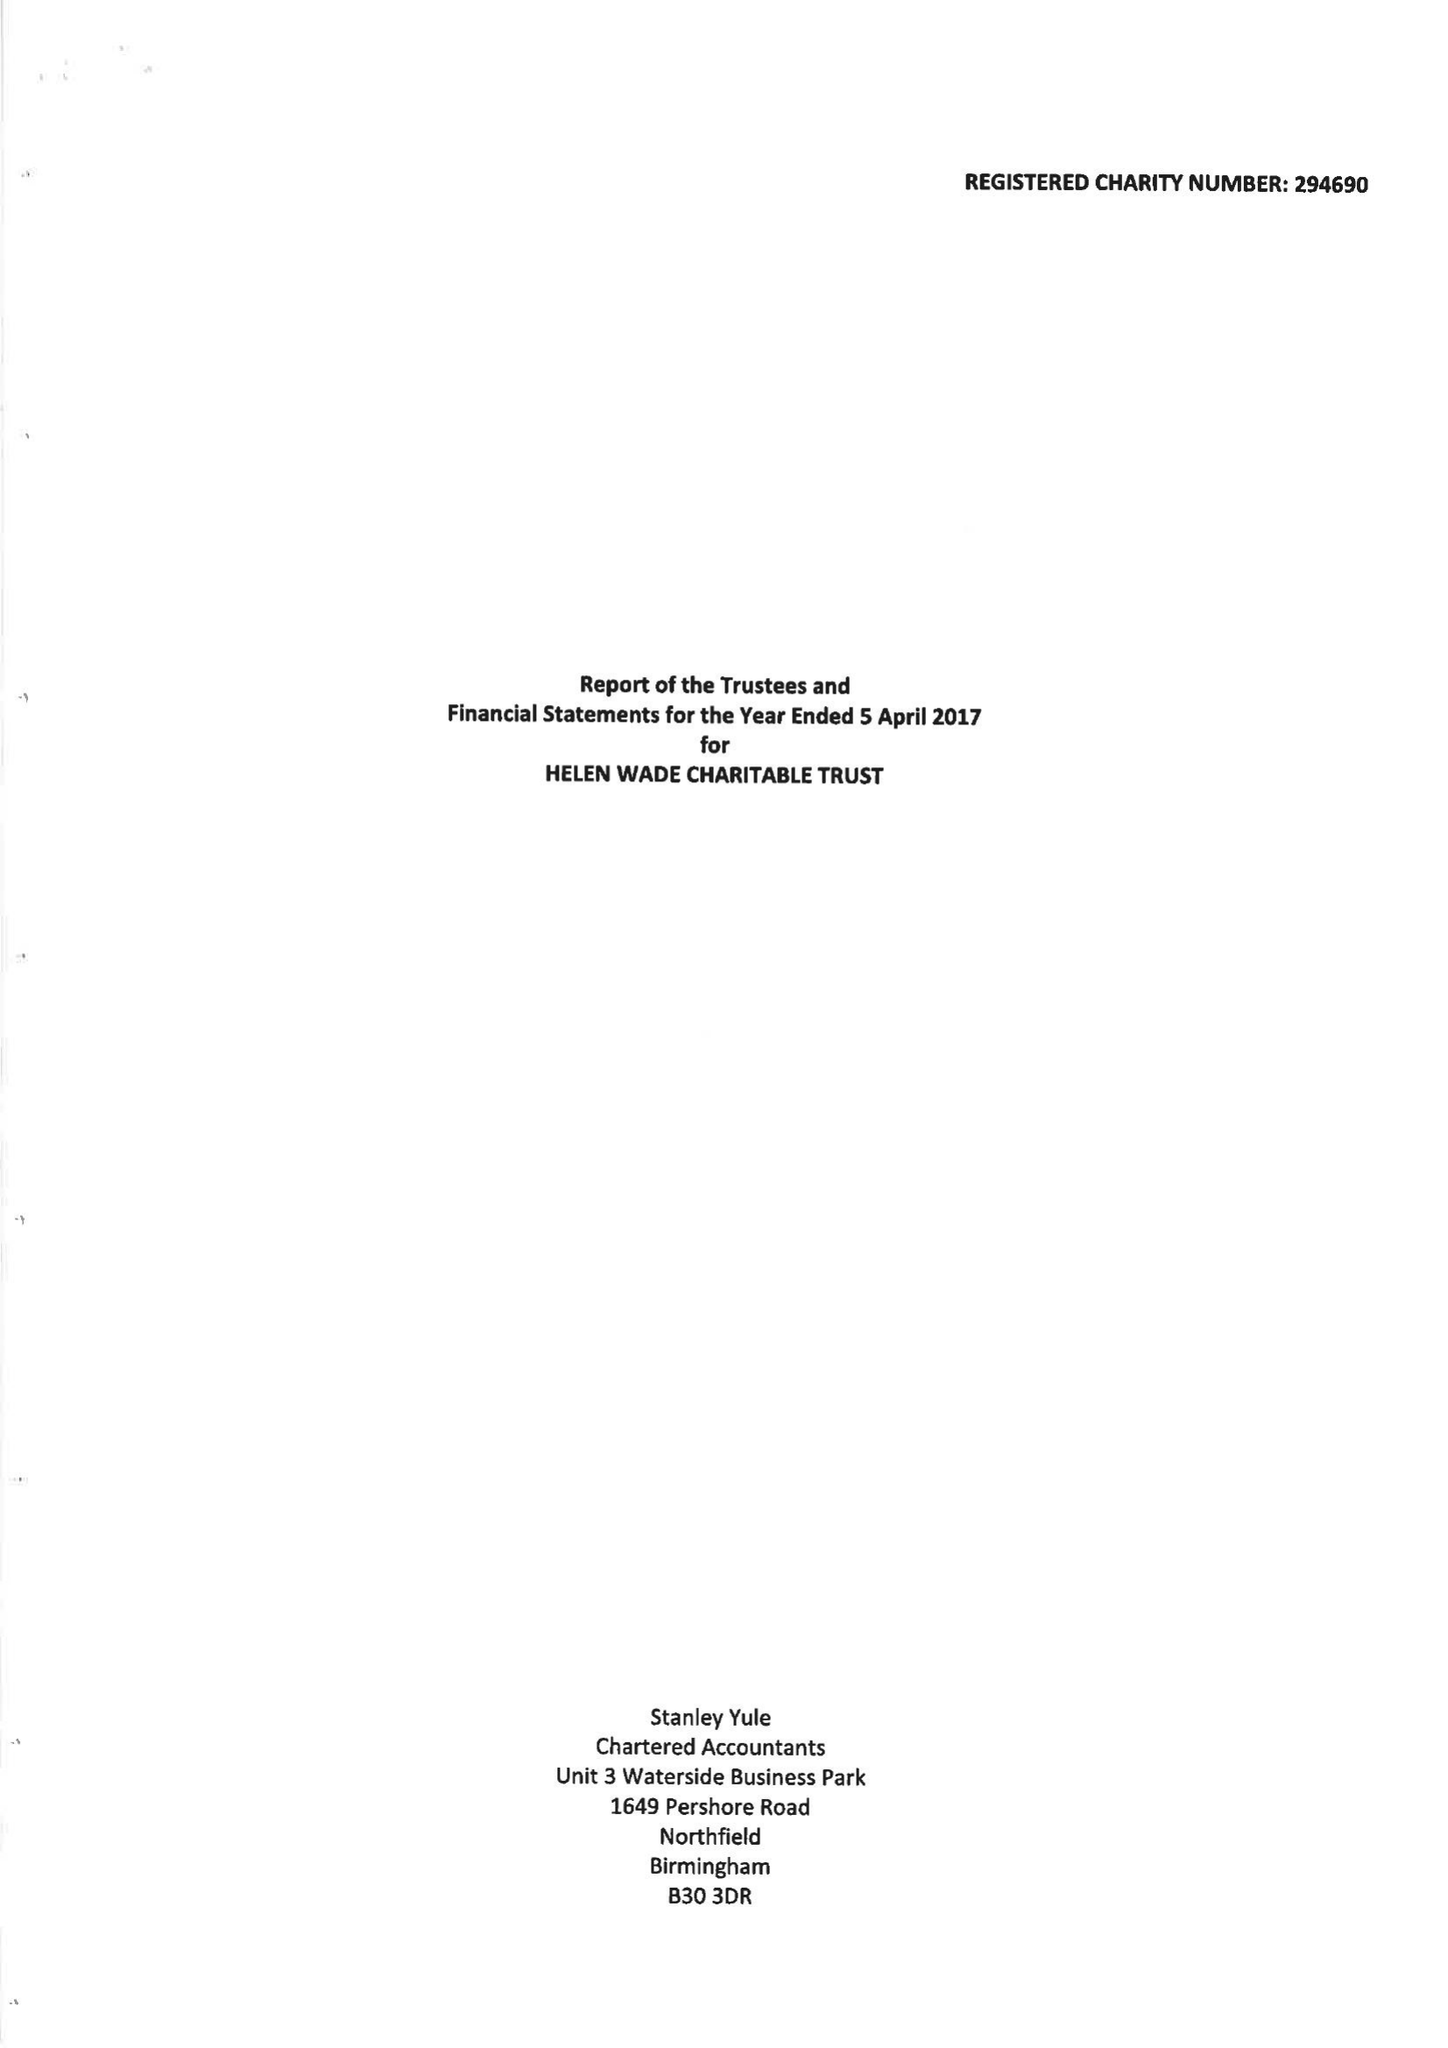What is the value for the charity_number?
Answer the question using a single word or phrase. 294690 